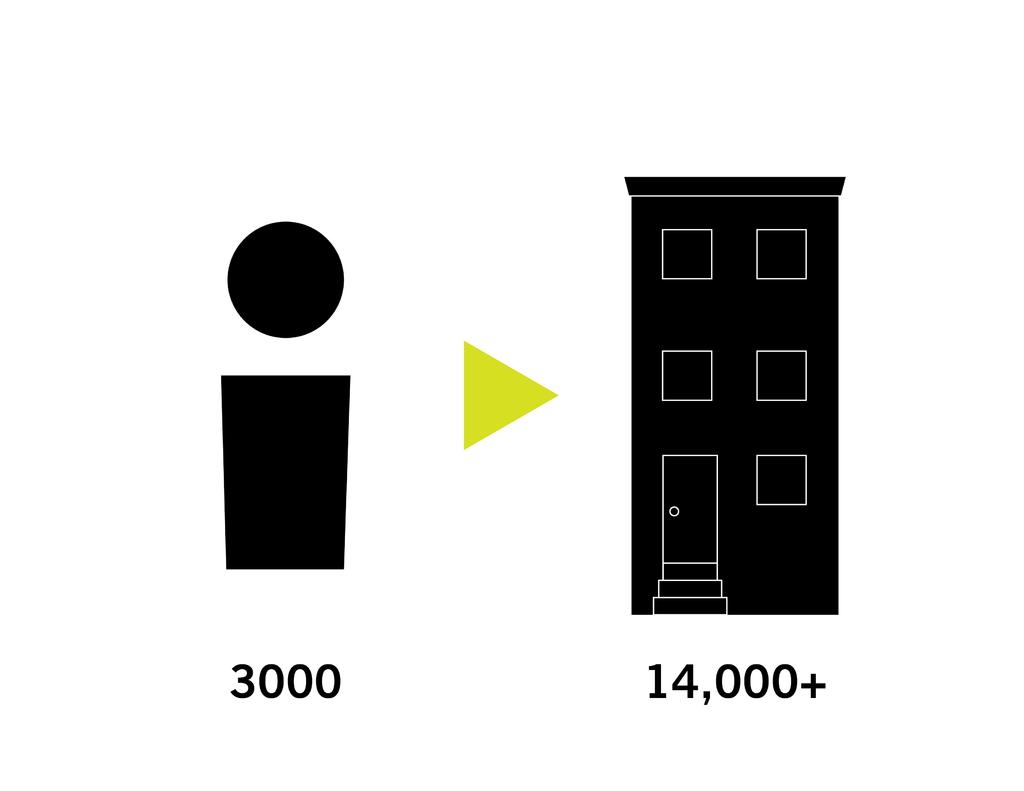<image>
Give a short and clear explanation of the subsequent image. A small box with a circle points to a building with the number 14,000+ below it. 